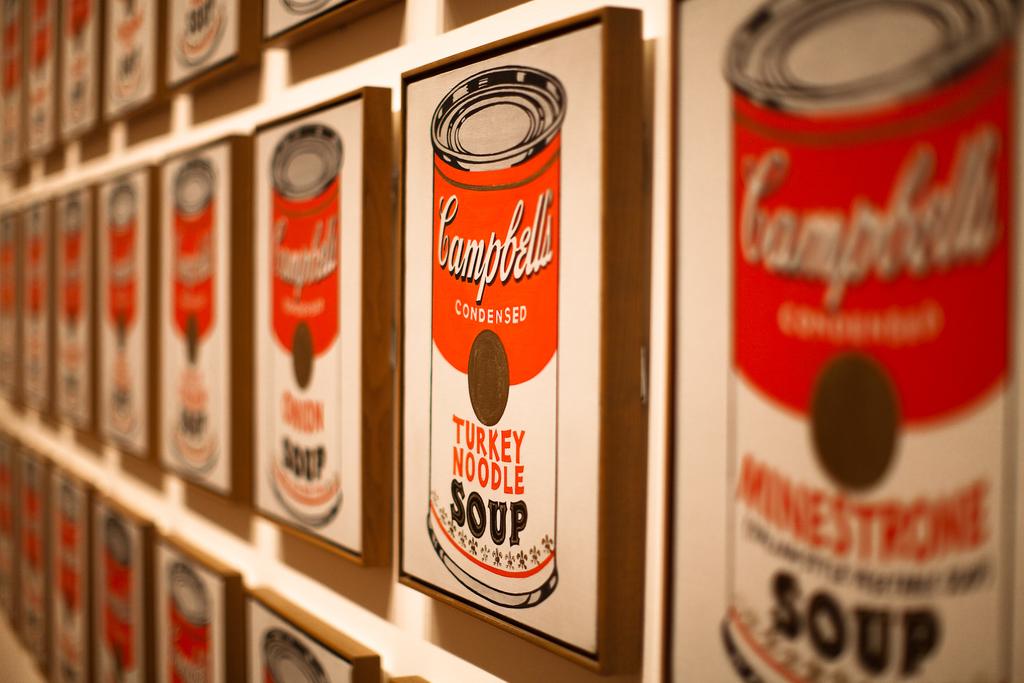What type of soup is listed on the can on the right?
Offer a terse response. Minestrone. What brand of soup is being displayed?
Ensure brevity in your answer.  Campbells. 